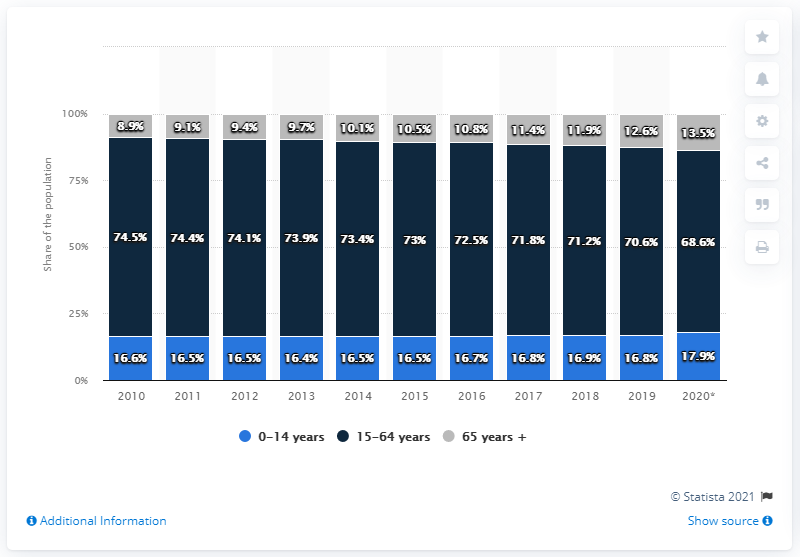Identify some key points in this picture. The smallest percentage of the age group 15-64 was observed in the year 2020. In the year 2017, the age group of 65 years and above comprised 11.4% of the total population. In 2020, approximately 13.5% of China's population was made up of retirees. 